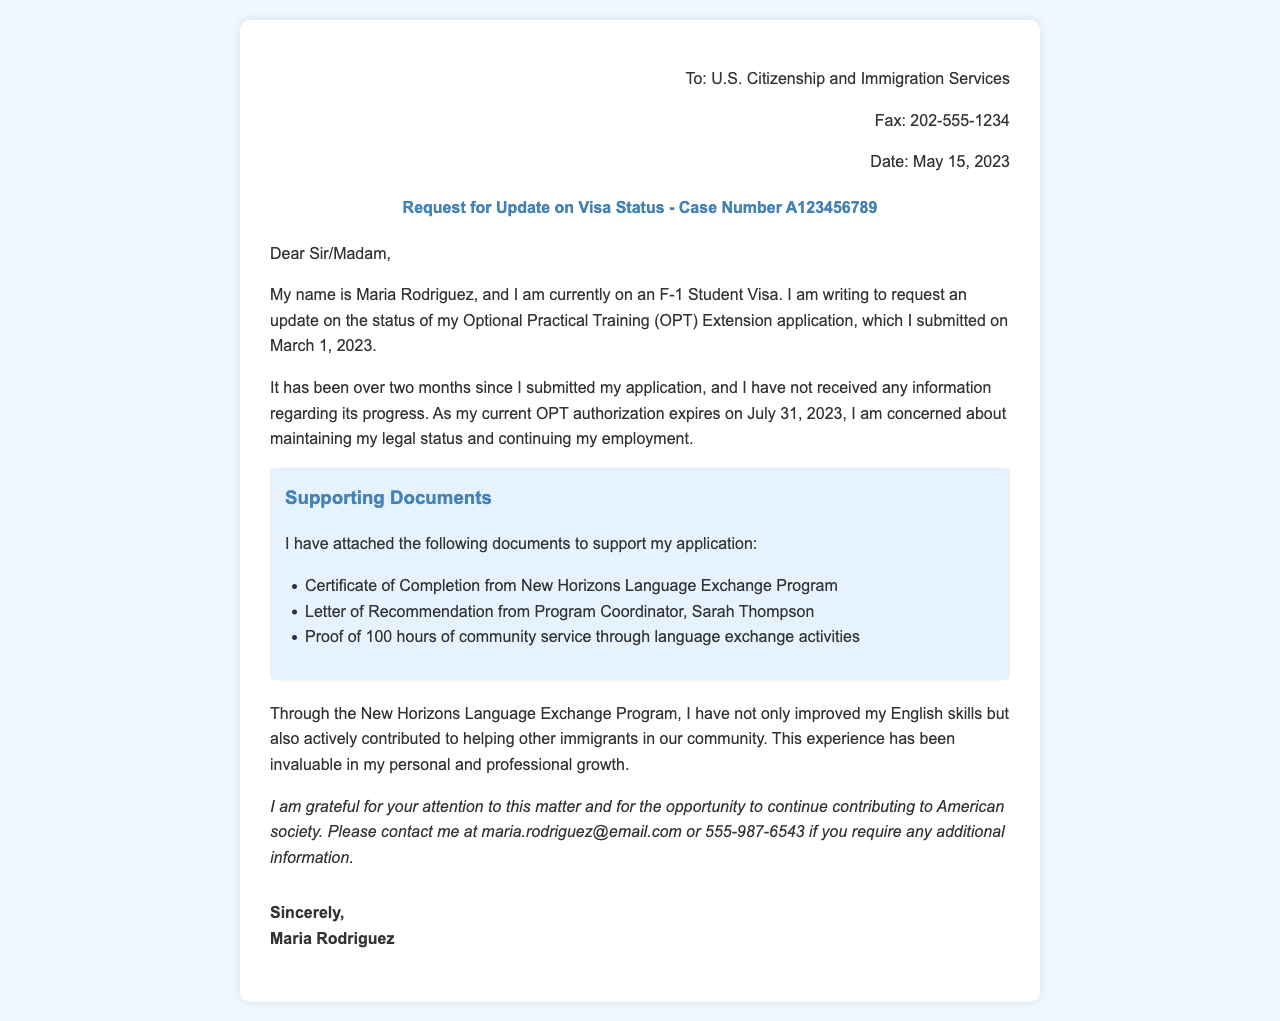What is the recipient's organization name? The recipient's organization is U.S. Citizenship and Immigration Services, as stated in the fax.
Answer: U.S. Citizenship and Immigration Services What is the date of the fax? The date of the fax is mentioned in the header section as May 15, 2023.
Answer: May 15, 2023 What is the case number referenced in the request? The case number provided in the request is specifically A123456789.
Answer: A123456789 Who is the program coordinator mentioned in the supporting documents? The program coordinator's name is Sarah Thompson, as listed in the letter of recommendation.
Answer: Sarah Thompson How many hours of community service has Maria Rodriguez completed? The document states Maria completed 100 hours of community service through language exchange activities.
Answer: 100 hours What type of visa is Maria currently on? The type of visa Maria is currently on is an F-1 Student Visa.
Answer: F-1 Student Visa What is the purpose of this fax? The purpose of the fax is to request an update on the status of Maria's OPT Extension application.
Answer: Request an update When was the OPT Extension application submitted? The OPT Extension application was submitted on March 1, 2023, according to the content of the fax.
Answer: March 1, 2023 What is the concern that Maria has regarding her visa status? Maria's concern is about maintaining her legal status and continuing her employment as her current OPT authorization is expiring.
Answer: Maintaining legal status and continuing employment 